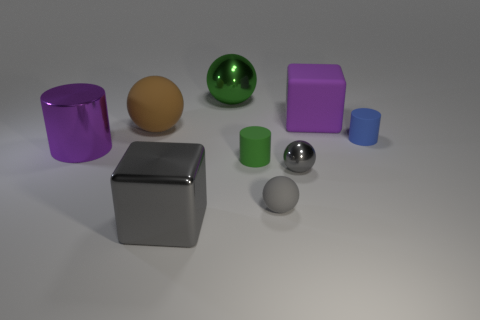What number of objects are large gray metal things on the left side of the tiny gray rubber thing or purple cylinders?
Offer a terse response. 2. Is the small blue object made of the same material as the gray object that is behind the gray matte ball?
Give a very brief answer. No. There is a purple object that is behind the metallic thing that is to the left of the metallic cube; what is its shape?
Your answer should be compact. Cube. There is a metallic block; is it the same color as the shiny thing behind the shiny cylinder?
Provide a short and direct response. No. Are there any other things that have the same material as the gray block?
Ensure brevity in your answer.  Yes. What is the shape of the brown thing?
Provide a short and direct response. Sphere. How big is the shiny ball that is in front of the large rubber thing in front of the purple rubber block?
Give a very brief answer. Small. Are there the same number of green shiny spheres that are in front of the large green sphere and small green matte things that are to the right of the tiny green cylinder?
Ensure brevity in your answer.  Yes. There is a object that is behind the blue rubber object and on the right side of the gray matte ball; what is its material?
Your answer should be very brief. Rubber. Do the purple cylinder and the sphere in front of the tiny shiny thing have the same size?
Make the answer very short. No. 